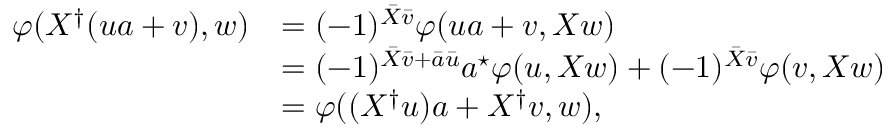Convert formula to latex. <formula><loc_0><loc_0><loc_500><loc_500>\begin{array} { r l } { \varphi ( X ^ { \dagger } ( u a + v ) , w ) } & { = ( - 1 ) ^ { \bar { X } \bar { v } } \varphi ( u a + v , X w ) } \\ & { = ( - 1 ) ^ { \bar { X } \bar { v } + \bar { a } \bar { u } } a ^ { ^ { * } } \varphi ( u , X w ) + ( - 1 ) ^ { \bar { X } \bar { v } } \varphi ( v , X w ) } \\ & { = \varphi ( ( X ^ { \dagger } u ) a + X ^ { \dagger } v , w ) , } \end{array}</formula> 